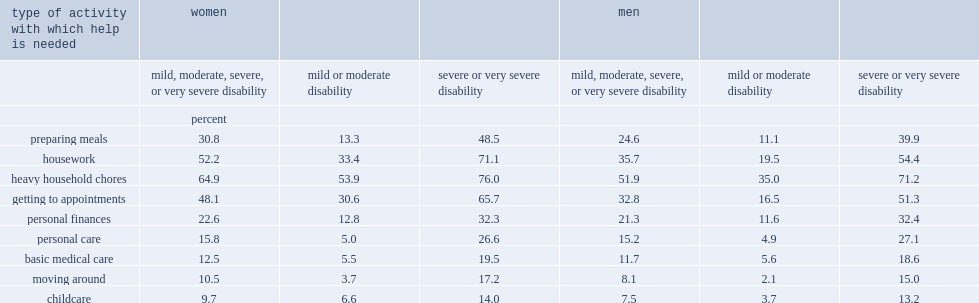Who were more likely to have reported needing help with heavy household chores, women or men? Women. Who were more likely to have reported needing help with housework, women or men? Women. Who were more likely to have reported needing help with getting to and from appointments, women or men? Women. Who were more likely to have reported needing help with preparing meals, women or men? Women. Who were more likely to have reported needing help with moving around, women or men? Women. Among aged 15 or older, who were more likely to required help with heavy household chores, women with severe or very severe disabilities or women with mild or moderate disabilities? Severe or very severe disability. Who were more likely to required help with housework, women with severe or very severe disabilities or women with mild or moderate disabilities? Severe or very severe disability. Who were more likely to required help with getting to appointments, women with severe or very severe disabilities or women with mild or moderate disabilities? Severe or very severe disability. Who were more likely to required help preparing meals, women with severe or very severe disabilities or women with mild or moderate disabilities? Severe or very severe disability. Among men with severe or very severe disabilities, what was the proportion of men reported needing help with heavy household chores? 71.2. Among men with severe or very severe disabilities, what was the proportion of men reported needing help with getting to appointments? 51.3. Among men with severe or very severe disabilities, what was the proportion of men reported needing help with preparing meals? 39.9. 